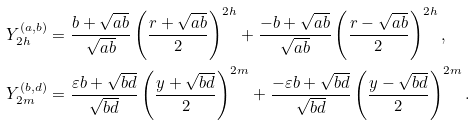<formula> <loc_0><loc_0><loc_500><loc_500>& Y _ { 2 h } ^ { ( a , b ) } = \frac { b + \sqrt { a b } } { \sqrt { a b } } \left ( \frac { r + \sqrt { a b } } { 2 } \right ) ^ { 2 h } + \frac { - b + \sqrt { a b } } { \sqrt { a b } } \left ( \frac { r - \sqrt { a b } } { 2 } \right ) ^ { 2 h } , \\ & Y _ { 2 m } ^ { ( b , d ) } = \frac { \varepsilon b + \sqrt { b d } } { \sqrt { b d } } \left ( \frac { y + \sqrt { b d } } { 2 } \right ) ^ { 2 m } + \frac { - \varepsilon b + \sqrt { b d } } { \sqrt { b d } } \left ( \frac { y - \sqrt { b d } } { 2 } \right ) ^ { 2 m } . \\</formula> 